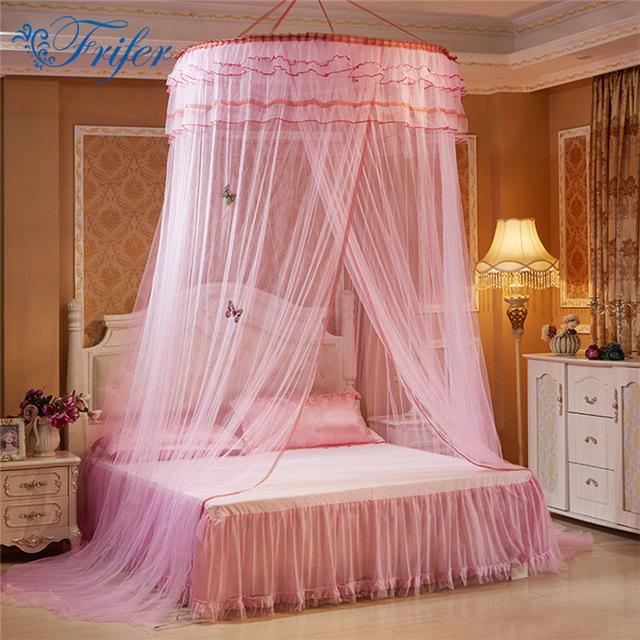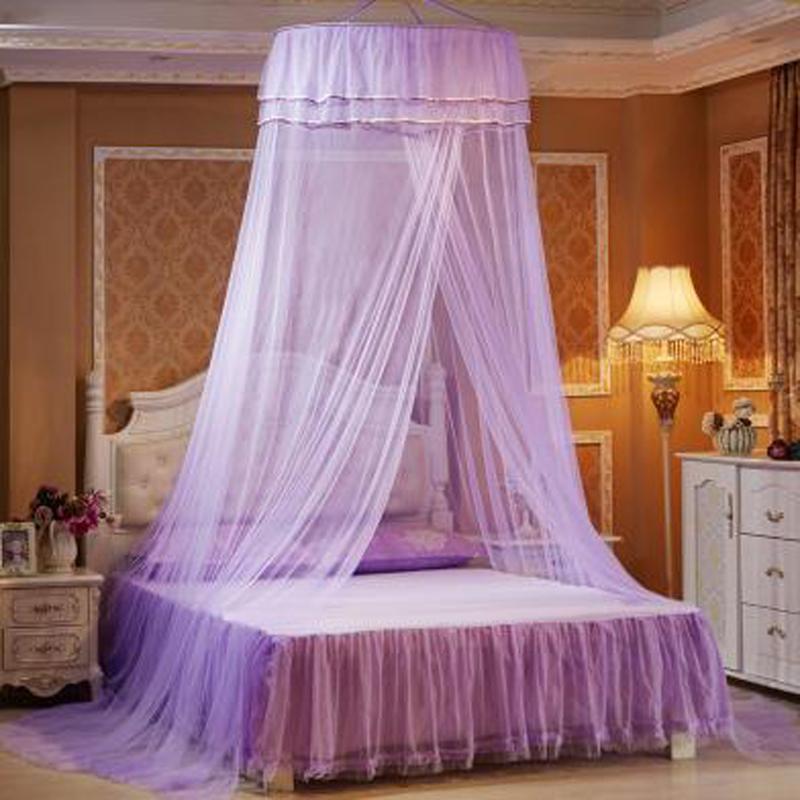The first image is the image on the left, the second image is the image on the right. Assess this claim about the two images: "All the nets are blue.". Correct or not? Answer yes or no. No. The first image is the image on the left, the second image is the image on the right. For the images shown, is this caption "The bed draperies in each image are similar in color and suspended from a circular framework over the bed." true? Answer yes or no. Yes. 